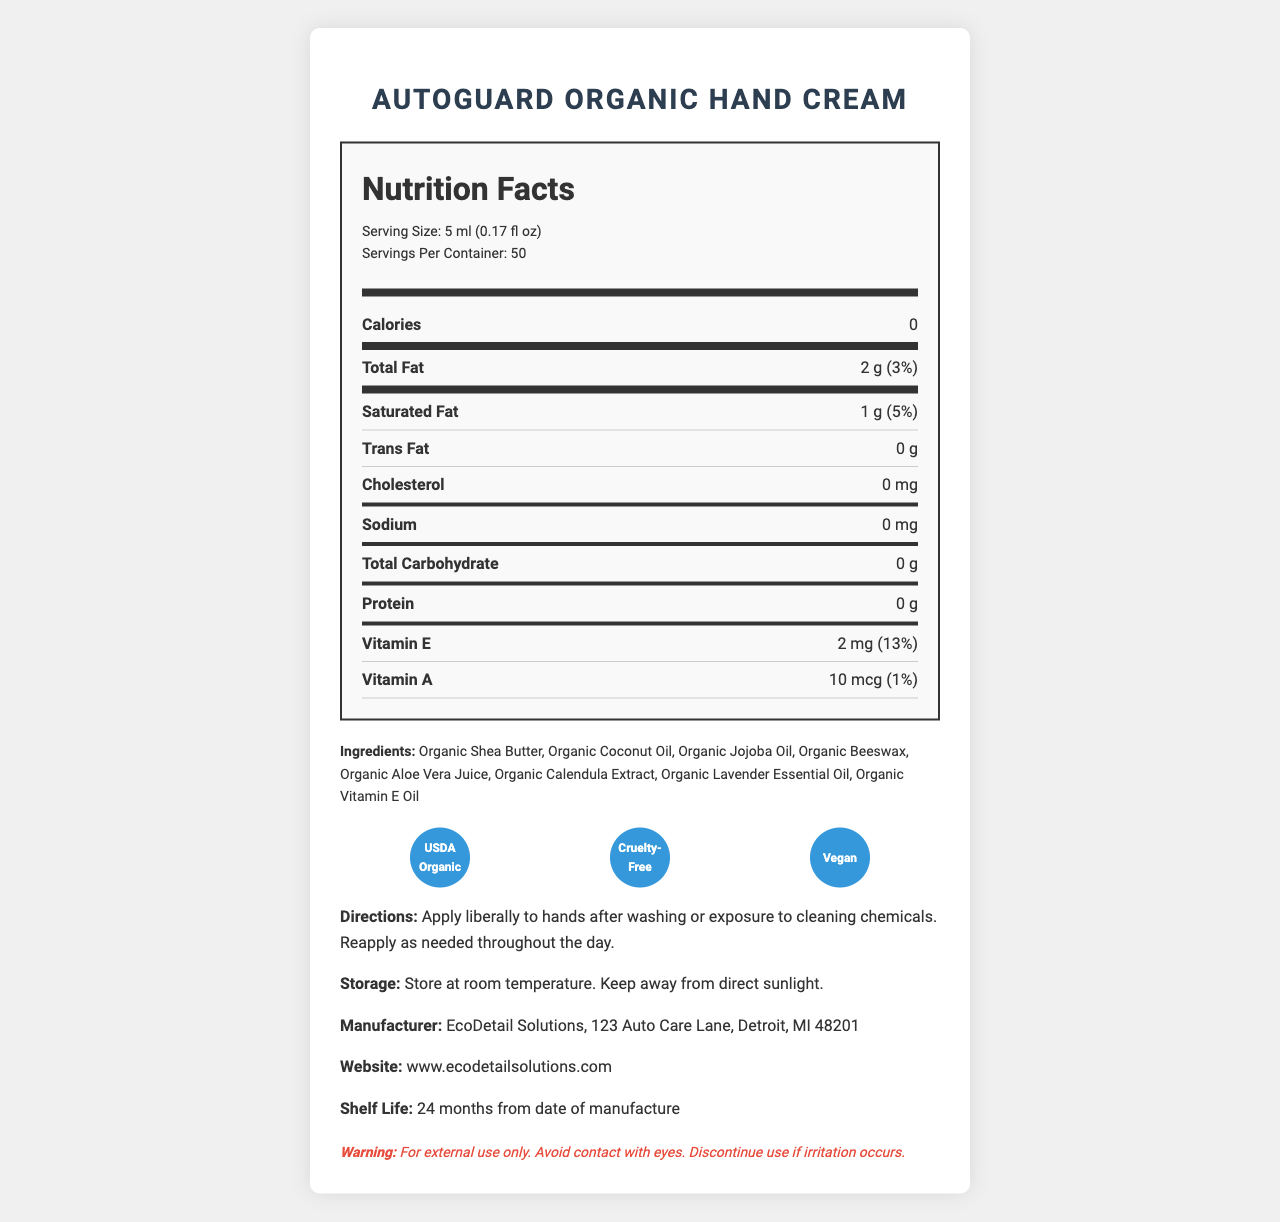what is the serving size? The serving size is stated clearly at the beginning of the Nutrition Facts section in the document.
Answer: 5 ml (0.17 fl oz) how many calories does each serving contain? The calories per serving are stated as 0 in the document.
Answer: 0 how many servings are in each container? The servings per container are listed as 50 in the document.
Answer: 50 what is the total fat content per serving? The total fat content per serving is listed as 2 g in the document.
Answer: 2 g what ingredients are used in the hand cream? The ingredients are listed in the Ingredients section of the document.
Answer: Organic Shea Butter, Organic Coconut Oil, Organic Jojoba Oil, Organic Beeswax, Organic Aloe Vera Juice, Organic Calendula Extract, Organic Lavender Essential Oil, Organic Vitamin E Oil which of the following is an ingredient? A. Organic Avocado Oil B. Organic Coconut Oil C. Organic Olive Oil D. Organic Castor Oil The document lists Organic Coconut Oil as one of the ingredients, but not the others.
Answer: B. Organic Coconut Oil what certifications does this hand cream have? The certifications are listed under the Certifications section with icon representations.
Answer: USDA Organic, Cruelty-Free, Vegan is the hand cream free from common allergens such as nuts, soy, gluten, and dairy? The allergen information specifies that the product is free from common allergens.
Answer: Yes what is the daily value percentage of Vitamin E per serving? The daily value percentage of Vitamin E per serving is listed as 13% in the document.
Answer: 13% describe the directions for using this hand cream. The directions are provided near the bottom of the document in the directions section.
Answer: Apply liberally to hands after washing or exposure to cleaning chemicals. Reapply as needed throughout the day. how much Vitamin A is in a serving? The amount of Vitamin A per serving is shown as 10 mcg in the Nutrition Facts section.
Answer: 10 mcg where is the manufacturer located? The manufacturer's address is given in the Manufacturer section of the document.
Answer: 123 Auto Care Lane, Detroit, MI 48201 is the packaging of this hand cream recyclable? The document specifies that the packaging is recyclable.
Answer: Yes how long is the shelf life of the product? The shelf life is mentioned as 24 months from the date of manufacture in the document.
Answer: 24 months from date of manufacture can this product be used internally? The warning statement specifies that the product is for external use only.
Answer: No what is the main idea of the document? The document aims to inform customers about the properties, usage, and safety of the AutoGuard Organic Hand Cream.
Answer: The document provides detailed information about AutoGuard Organic Hand Cream, including its nutrition facts, ingredients, usage directions, storage instructions, manufacturer details, certifications, and safety warnings. what is the pH value of the hand cream? The document does not provide specific information about the pH value of the hand cream.
Answer: Not enough information 